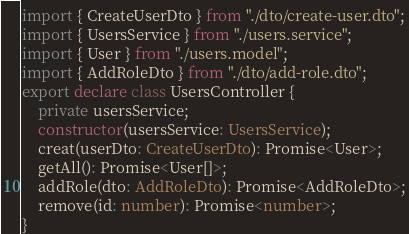<code> <loc_0><loc_0><loc_500><loc_500><_TypeScript_>import { CreateUserDto } from "./dto/create-user.dto";
import { UsersService } from "./users.service";
import { User } from "./users.model";
import { AddRoleDto } from "./dto/add-role.dto";
export declare class UsersController {
    private usersService;
    constructor(usersService: UsersService);
    creat(userDto: CreateUserDto): Promise<User>;
    getAll(): Promise<User[]>;
    addRole(dto: AddRoleDto): Promise<AddRoleDto>;
    remove(id: number): Promise<number>;
}
</code> 